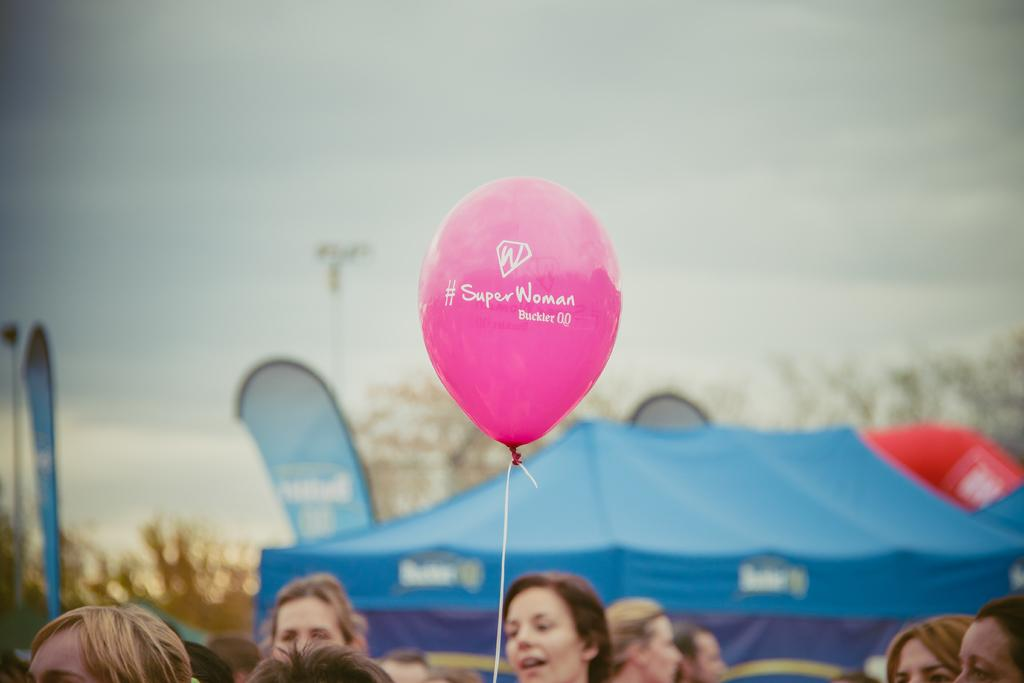How many people are in the image? There are persons in the image, but the exact number is not specified. What object can be seen floating in the image? There is a balloon in the image. What type of shelter is present in the image? There is a tent in the image. What type of decoration is present in the image? There are banners in the image. What type of natural vegetation is present in the image? There are trees in the image. What is visible in the background of the image? The sky is visible in the background of the image. What type of waves can be seen in the image? There are no waves present in the image. What is the belief of the persons in the image? The provided facts do not mention any beliefs of the persons in the image. 